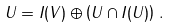<formula> <loc_0><loc_0><loc_500><loc_500>U = I ( V ) \oplus \left ( U \cap I ( U ) \right ) \, .</formula> 